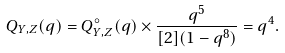Convert formula to latex. <formula><loc_0><loc_0><loc_500><loc_500>Q _ { Y , Z } ( q ) = Q _ { Y , Z } ^ { \circ } ( q ) \times \frac { q ^ { 5 } } { [ 2 ] ( 1 - q ^ { 8 } ) } = q ^ { 4 } .</formula> 